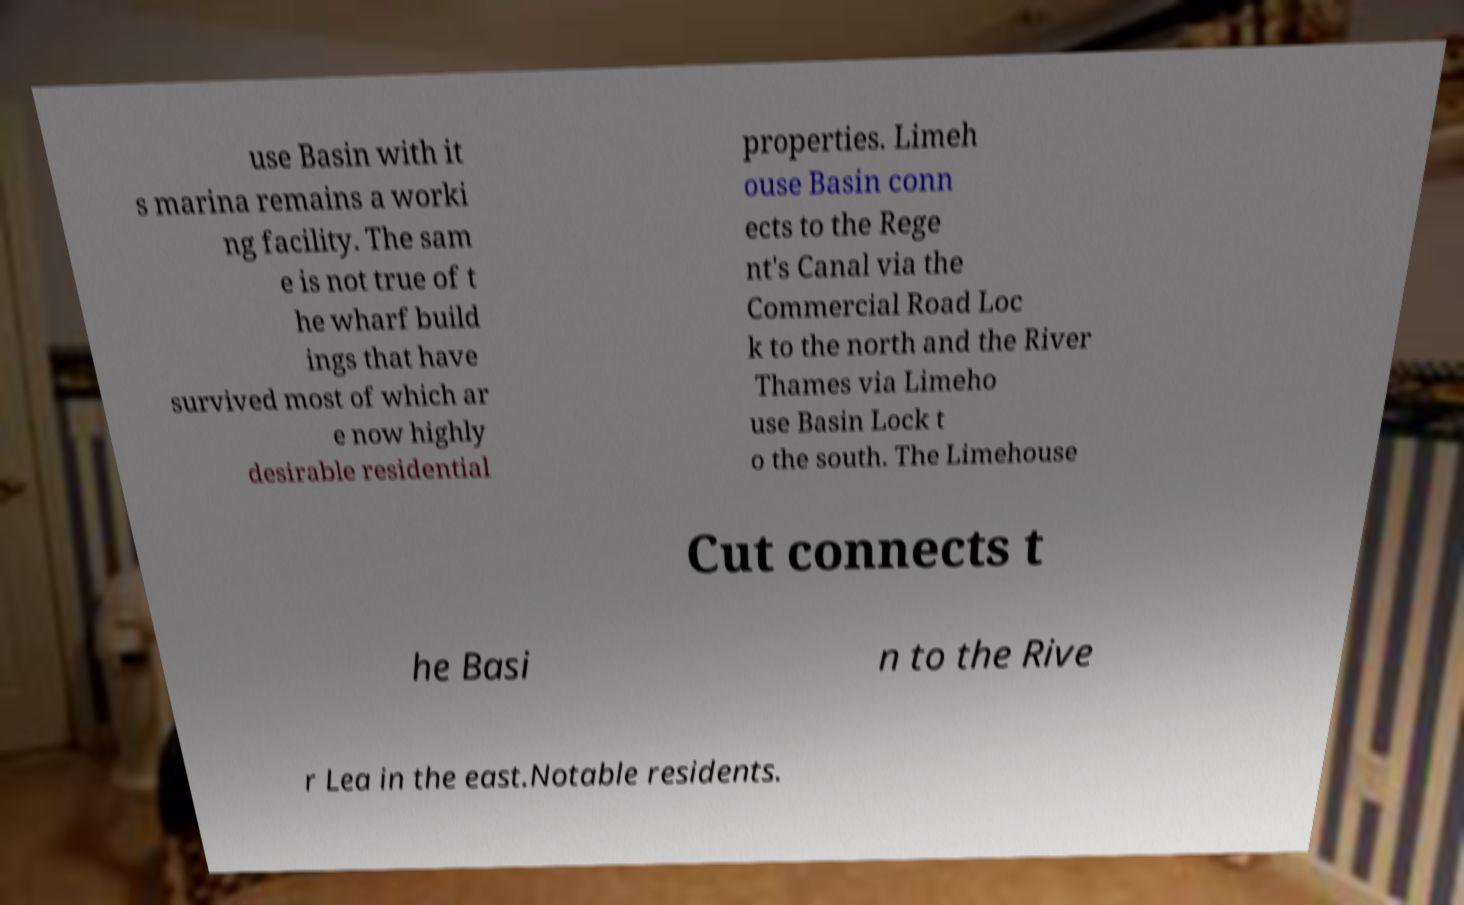Can you accurately transcribe the text from the provided image for me? use Basin with it s marina remains a worki ng facility. The sam e is not true of t he wharf build ings that have survived most of which ar e now highly desirable residential properties. Limeh ouse Basin conn ects to the Rege nt's Canal via the Commercial Road Loc k to the north and the River Thames via Limeho use Basin Lock t o the south. The Limehouse Cut connects t he Basi n to the Rive r Lea in the east.Notable residents. 